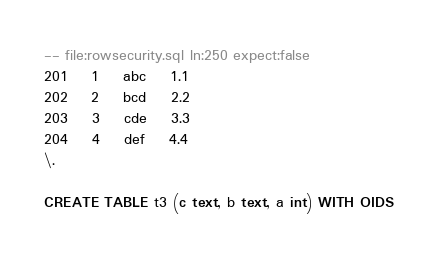Convert code to text. <code><loc_0><loc_0><loc_500><loc_500><_SQL_>-- file:rowsecurity.sql ln:250 expect:false
201	1	abc	1.1
202	2	bcd	2.2
203	3	cde	3.3
204	4	def	4.4
\.

CREATE TABLE t3 (c text, b text, a int) WITH OIDS
</code> 